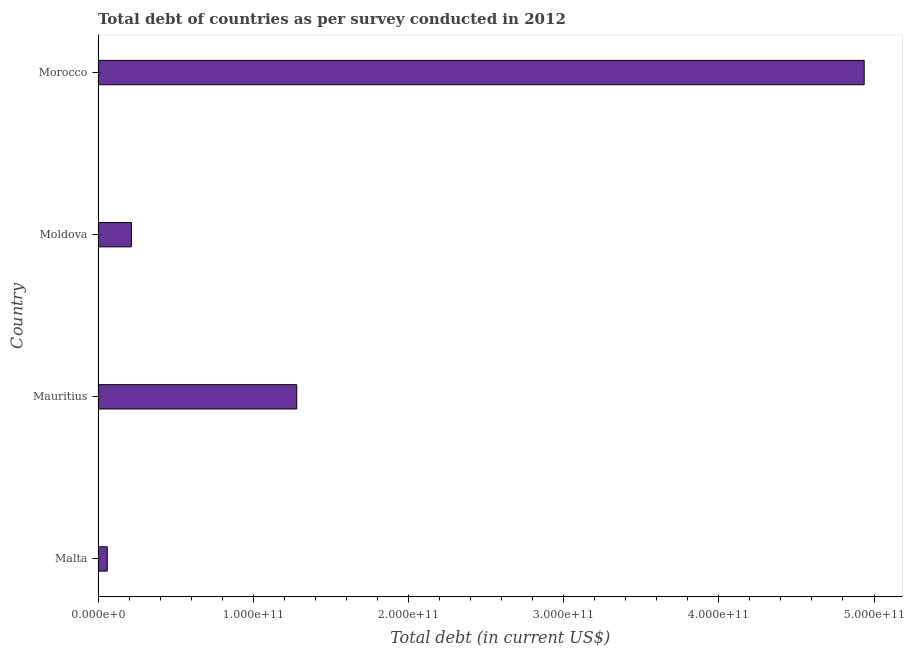Does the graph contain any zero values?
Your answer should be very brief. No. Does the graph contain grids?
Keep it short and to the point. No. What is the title of the graph?
Provide a short and direct response. Total debt of countries as per survey conducted in 2012. What is the label or title of the X-axis?
Keep it short and to the point. Total debt (in current US$). What is the total debt in Mauritius?
Your answer should be compact. 1.28e+11. Across all countries, what is the maximum total debt?
Your response must be concise. 4.94e+11. Across all countries, what is the minimum total debt?
Give a very brief answer. 5.94e+09. In which country was the total debt maximum?
Offer a very short reply. Morocco. In which country was the total debt minimum?
Offer a terse response. Malta. What is the sum of the total debt?
Keep it short and to the point. 6.49e+11. What is the difference between the total debt in Mauritius and Morocco?
Your answer should be compact. -3.66e+11. What is the average total debt per country?
Offer a very short reply. 1.62e+11. What is the median total debt?
Provide a short and direct response. 7.47e+1. What is the ratio of the total debt in Mauritius to that in Moldova?
Provide a succinct answer. 5.96. What is the difference between the highest and the second highest total debt?
Your answer should be very brief. 3.66e+11. Is the sum of the total debt in Mauritius and Morocco greater than the maximum total debt across all countries?
Provide a succinct answer. Yes. What is the difference between the highest and the lowest total debt?
Your answer should be very brief. 4.88e+11. Are all the bars in the graph horizontal?
Ensure brevity in your answer.  Yes. What is the difference between two consecutive major ticks on the X-axis?
Offer a terse response. 1.00e+11. Are the values on the major ticks of X-axis written in scientific E-notation?
Provide a short and direct response. Yes. What is the Total debt (in current US$) in Malta?
Your answer should be compact. 5.94e+09. What is the Total debt (in current US$) of Mauritius?
Offer a very short reply. 1.28e+11. What is the Total debt (in current US$) of Moldova?
Provide a short and direct response. 2.15e+1. What is the Total debt (in current US$) in Morocco?
Offer a very short reply. 4.94e+11. What is the difference between the Total debt (in current US$) in Malta and Mauritius?
Your answer should be compact. -1.22e+11. What is the difference between the Total debt (in current US$) in Malta and Moldova?
Make the answer very short. -1.55e+1. What is the difference between the Total debt (in current US$) in Malta and Morocco?
Provide a short and direct response. -4.88e+11. What is the difference between the Total debt (in current US$) in Mauritius and Moldova?
Offer a terse response. 1.07e+11. What is the difference between the Total debt (in current US$) in Mauritius and Morocco?
Provide a succinct answer. -3.66e+11. What is the difference between the Total debt (in current US$) in Moldova and Morocco?
Provide a succinct answer. -4.72e+11. What is the ratio of the Total debt (in current US$) in Malta to that in Mauritius?
Your answer should be compact. 0.05. What is the ratio of the Total debt (in current US$) in Malta to that in Moldova?
Your answer should be compact. 0.28. What is the ratio of the Total debt (in current US$) in Malta to that in Morocco?
Your response must be concise. 0.01. What is the ratio of the Total debt (in current US$) in Mauritius to that in Moldova?
Your response must be concise. 5.96. What is the ratio of the Total debt (in current US$) in Mauritius to that in Morocco?
Your answer should be very brief. 0.26. What is the ratio of the Total debt (in current US$) in Moldova to that in Morocco?
Your response must be concise. 0.04. 